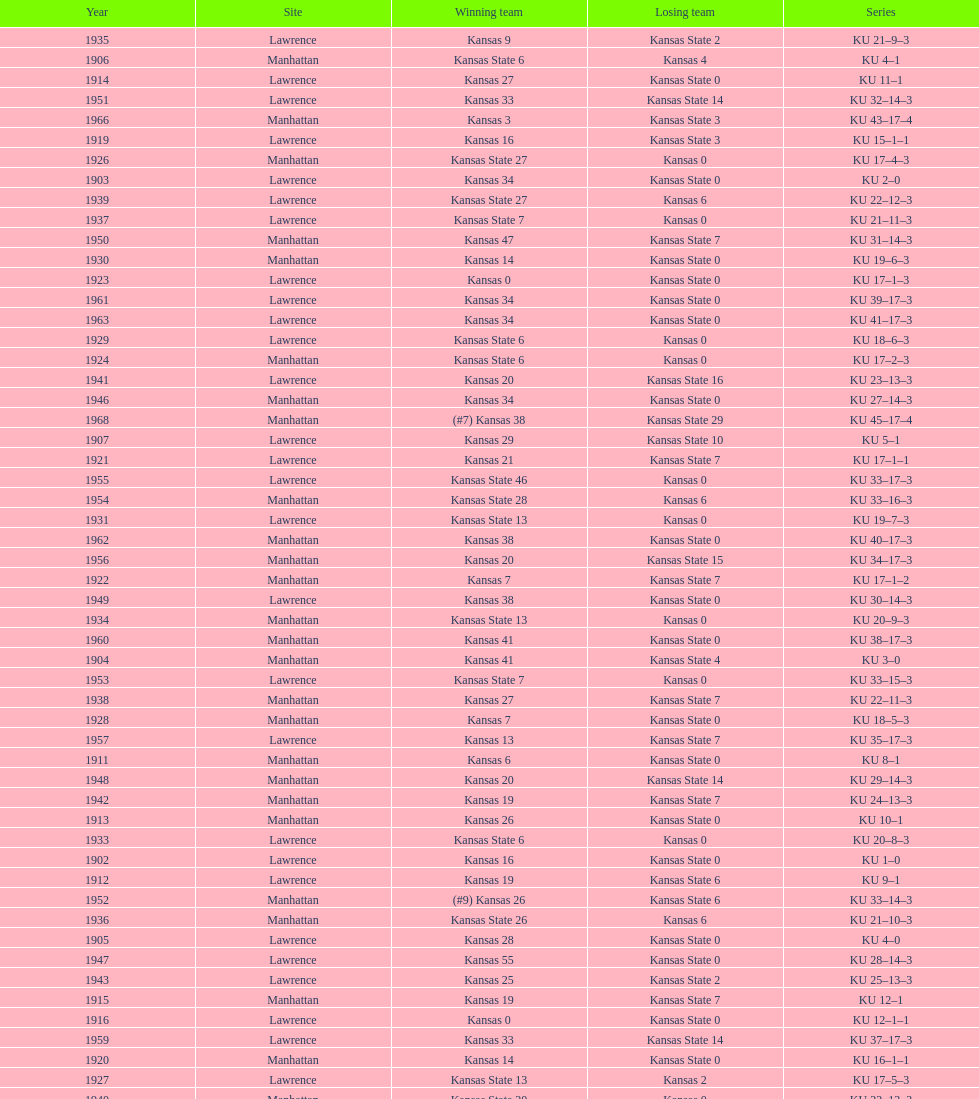When was the last time kansas state lost with 0 points in manhattan? 1964. 